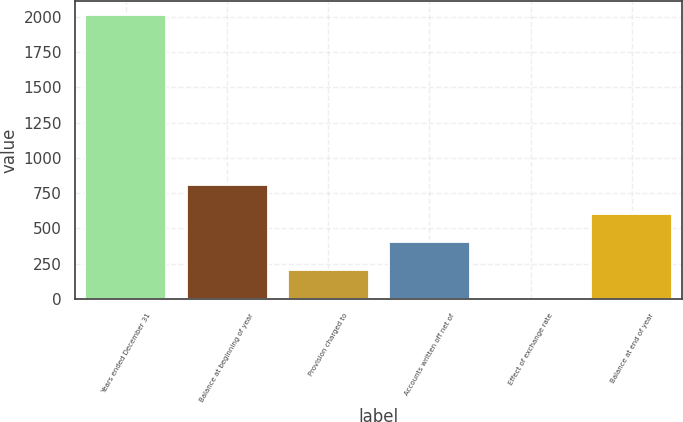<chart> <loc_0><loc_0><loc_500><loc_500><bar_chart><fcel>Years ended December 31<fcel>Balance at beginning of year<fcel>Provision charged to<fcel>Accounts written off net of<fcel>Effect of exchange rate<fcel>Balance at end of year<nl><fcel>2013<fcel>805.8<fcel>202.2<fcel>403.4<fcel>1<fcel>604.6<nl></chart> 